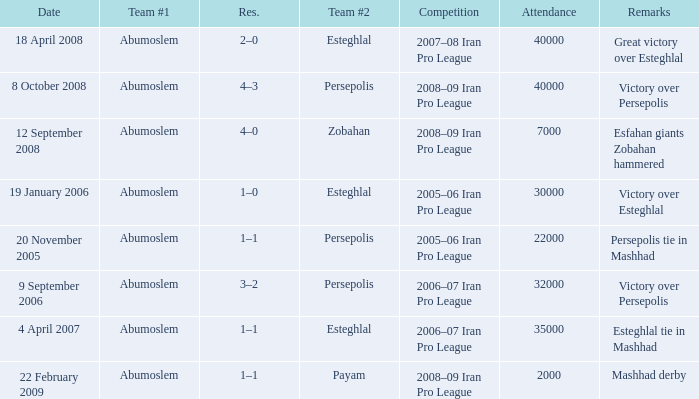What was the res for the game against Payam? 1–1. 